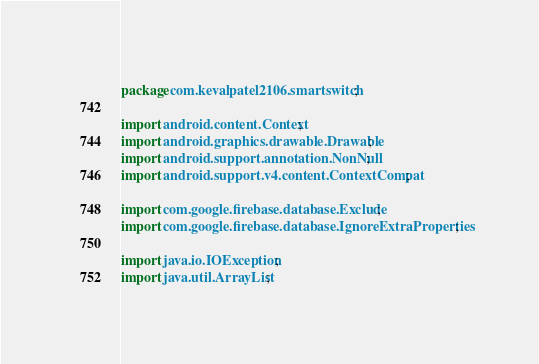Convert code to text. <code><loc_0><loc_0><loc_500><loc_500><_Java_>package com.kevalpatel2106.smartswitch;

import android.content.Context;
import android.graphics.drawable.Drawable;
import android.support.annotation.NonNull;
import android.support.v4.content.ContextCompat;

import com.google.firebase.database.Exclude;
import com.google.firebase.database.IgnoreExtraProperties;

import java.io.IOException;
import java.util.ArrayList;
</code> 